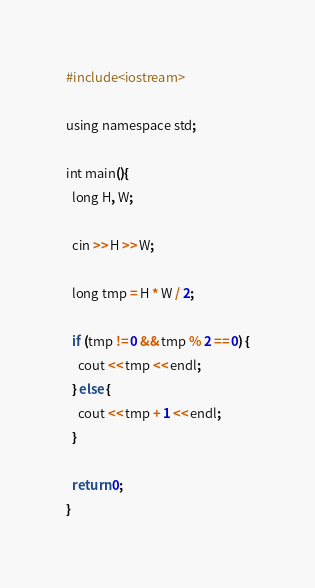<code> <loc_0><loc_0><loc_500><loc_500><_Ruby_>#include<iostream>

using namespace std;

int main(){
  long H, W;

  cin >> H >> W;

  long tmp = H * W / 2;

  if (tmp != 0 && tmp % 2 == 0) {
    cout << tmp << endl;
  } else {
    cout << tmp + 1 << endl;
  }

  return 0;
}
</code> 